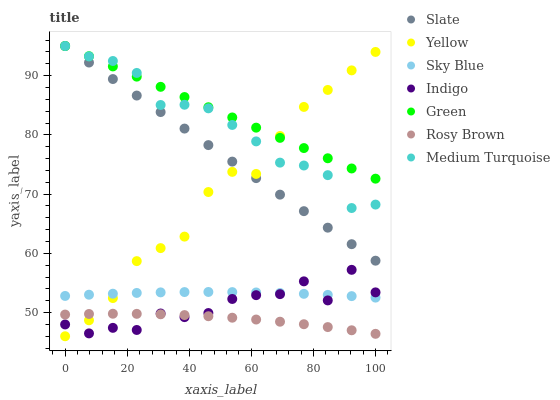Does Rosy Brown have the minimum area under the curve?
Answer yes or no. Yes. Does Green have the maximum area under the curve?
Answer yes or no. Yes. Does Slate have the minimum area under the curve?
Answer yes or no. No. Does Slate have the maximum area under the curve?
Answer yes or no. No. Is Green the smoothest?
Answer yes or no. Yes. Is Indigo the roughest?
Answer yes or no. Yes. Is Slate the smoothest?
Answer yes or no. No. Is Slate the roughest?
Answer yes or no. No. Does Yellow have the lowest value?
Answer yes or no. Yes. Does Slate have the lowest value?
Answer yes or no. No. Does Medium Turquoise have the highest value?
Answer yes or no. Yes. Does Rosy Brown have the highest value?
Answer yes or no. No. Is Rosy Brown less than Sky Blue?
Answer yes or no. Yes. Is Slate greater than Sky Blue?
Answer yes or no. Yes. Does Yellow intersect Green?
Answer yes or no. Yes. Is Yellow less than Green?
Answer yes or no. No. Is Yellow greater than Green?
Answer yes or no. No. Does Rosy Brown intersect Sky Blue?
Answer yes or no. No. 